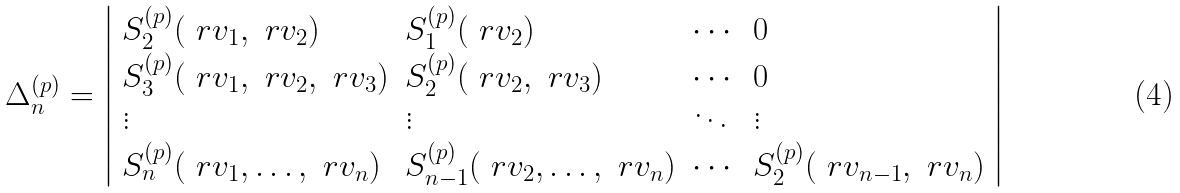<formula> <loc_0><loc_0><loc_500><loc_500>\Delta ^ { ( p ) } _ { n } = \left | \begin{array} { l l l l } S _ { 2 } ^ { ( p ) } ( \ r v _ { 1 } , \ r v _ { 2 } ) & S _ { 1 } ^ { ( p ) } ( \ r v _ { 2 } ) & \cdots & 0 \\ S ^ { ( p ) } _ { 3 } ( \ r v _ { 1 } , \ r v _ { 2 } , \ r v _ { 3 } ) & S ^ { ( p ) } _ { 2 } ( \ r v _ { 2 } , \ r v _ { 3 } ) & \cdots & 0 \\ \vdots & \vdots & \ddots & \vdots \\ S ^ { ( p ) } _ { n } ( \ r v _ { 1 } , \dots , \ r v _ { n } ) & S ^ { ( p ) } _ { n - 1 } ( \ r v _ { 2 } , \dots , \ r v _ { n } ) & \cdots & S ^ { ( p ) } _ { 2 } ( \ r v _ { n - 1 } , \ r v _ { n } ) \end{array} \right |</formula> 